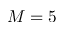Convert formula to latex. <formula><loc_0><loc_0><loc_500><loc_500>M = 5</formula> 